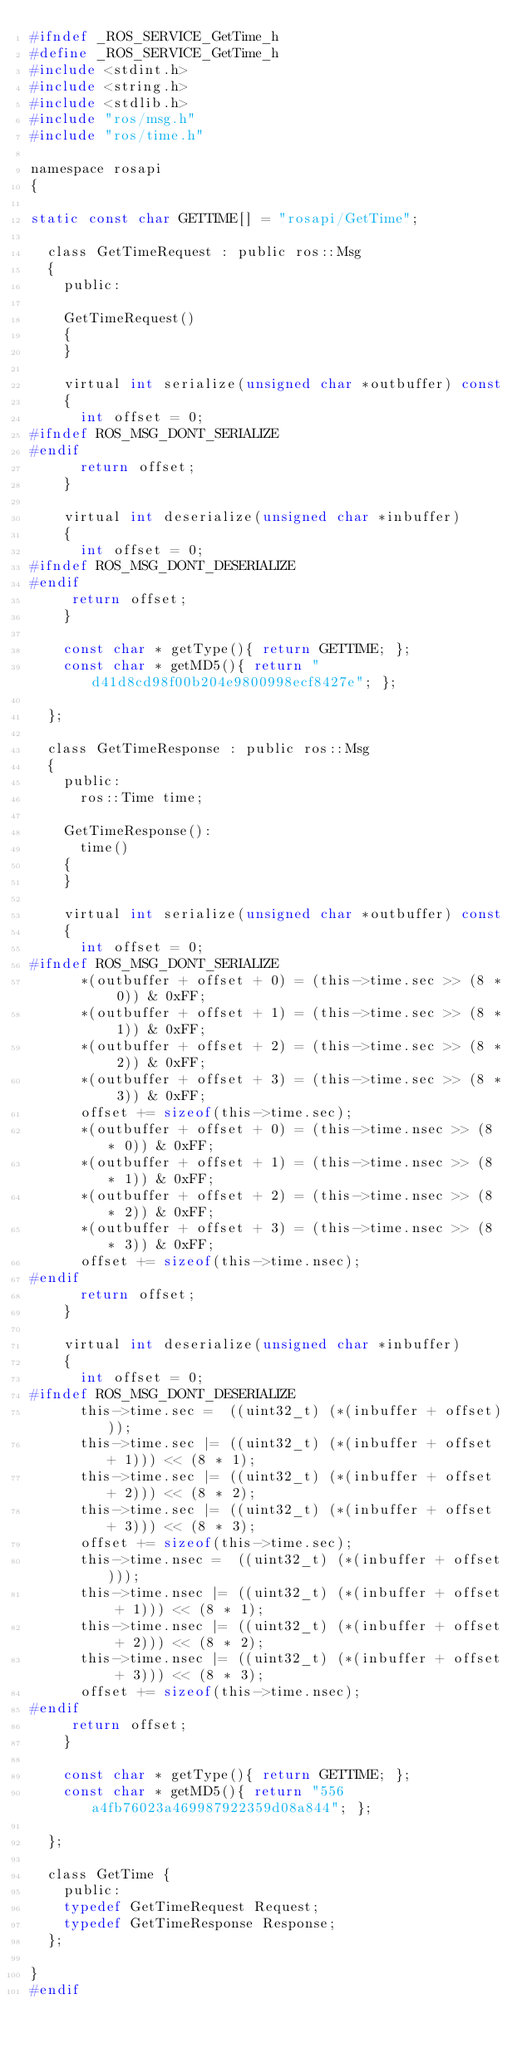Convert code to text. <code><loc_0><loc_0><loc_500><loc_500><_C_>#ifndef _ROS_SERVICE_GetTime_h
#define _ROS_SERVICE_GetTime_h
#include <stdint.h>
#include <string.h>
#include <stdlib.h>
#include "ros/msg.h"
#include "ros/time.h"

namespace rosapi
{

static const char GETTIME[] = "rosapi/GetTime";

  class GetTimeRequest : public ros::Msg
  {
    public:

    GetTimeRequest()
    {
    }

    virtual int serialize(unsigned char *outbuffer) const
    {
      int offset = 0;
#ifndef ROS_MSG_DONT_SERIALIZE
#endif
      return offset;
    }

    virtual int deserialize(unsigned char *inbuffer)
    {
      int offset = 0;
#ifndef ROS_MSG_DONT_DESERIALIZE
#endif
     return offset;
    }

    const char * getType(){ return GETTIME; };
    const char * getMD5(){ return "d41d8cd98f00b204e9800998ecf8427e"; };

  };

  class GetTimeResponse : public ros::Msg
  {
    public:
      ros::Time time;

    GetTimeResponse():
      time()
    {
    }

    virtual int serialize(unsigned char *outbuffer) const
    {
      int offset = 0;
#ifndef ROS_MSG_DONT_SERIALIZE
      *(outbuffer + offset + 0) = (this->time.sec >> (8 * 0)) & 0xFF;
      *(outbuffer + offset + 1) = (this->time.sec >> (8 * 1)) & 0xFF;
      *(outbuffer + offset + 2) = (this->time.sec >> (8 * 2)) & 0xFF;
      *(outbuffer + offset + 3) = (this->time.sec >> (8 * 3)) & 0xFF;
      offset += sizeof(this->time.sec);
      *(outbuffer + offset + 0) = (this->time.nsec >> (8 * 0)) & 0xFF;
      *(outbuffer + offset + 1) = (this->time.nsec >> (8 * 1)) & 0xFF;
      *(outbuffer + offset + 2) = (this->time.nsec >> (8 * 2)) & 0xFF;
      *(outbuffer + offset + 3) = (this->time.nsec >> (8 * 3)) & 0xFF;
      offset += sizeof(this->time.nsec);
#endif
      return offset;
    }

    virtual int deserialize(unsigned char *inbuffer)
    {
      int offset = 0;
#ifndef ROS_MSG_DONT_DESERIALIZE
      this->time.sec =  ((uint32_t) (*(inbuffer + offset)));
      this->time.sec |= ((uint32_t) (*(inbuffer + offset + 1))) << (8 * 1);
      this->time.sec |= ((uint32_t) (*(inbuffer + offset + 2))) << (8 * 2);
      this->time.sec |= ((uint32_t) (*(inbuffer + offset + 3))) << (8 * 3);
      offset += sizeof(this->time.sec);
      this->time.nsec =  ((uint32_t) (*(inbuffer + offset)));
      this->time.nsec |= ((uint32_t) (*(inbuffer + offset + 1))) << (8 * 1);
      this->time.nsec |= ((uint32_t) (*(inbuffer + offset + 2))) << (8 * 2);
      this->time.nsec |= ((uint32_t) (*(inbuffer + offset + 3))) << (8 * 3);
      offset += sizeof(this->time.nsec);
#endif
     return offset;
    }

    const char * getType(){ return GETTIME; };
    const char * getMD5(){ return "556a4fb76023a469987922359d08a844"; };

  };

  class GetTime {
    public:
    typedef GetTimeRequest Request;
    typedef GetTimeResponse Response;
  };

}
#endif
</code> 